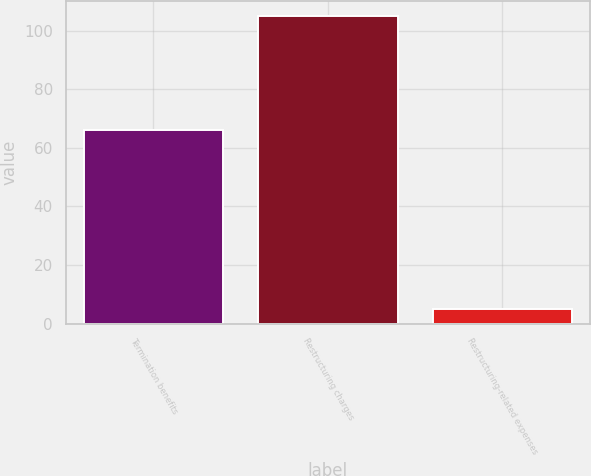Convert chart to OTSL. <chart><loc_0><loc_0><loc_500><loc_500><bar_chart><fcel>Termination benefits<fcel>Restructuring charges<fcel>Restructuring-related expenses<nl><fcel>66<fcel>105<fcel>5<nl></chart> 